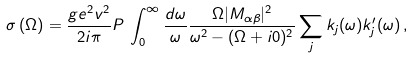Convert formula to latex. <formula><loc_0><loc_0><loc_500><loc_500>\sigma \left ( \Omega \right ) = \frac { g e ^ { 2 } v ^ { 2 } } { 2 i \pi } P \, \int _ { 0 } ^ { \infty } \frac { d \omega } { \omega } \frac { \Omega | M _ { \alpha \beta } | ^ { 2 } } { \omega ^ { 2 } - ( \Omega + i 0 ) ^ { 2 } } \sum _ { j } k _ { j } ( \omega ) k _ { j } ^ { \prime } ( \omega ) \, ,</formula> 